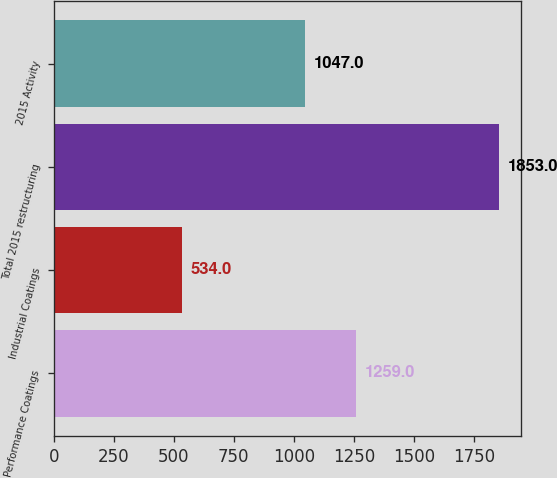Convert chart. <chart><loc_0><loc_0><loc_500><loc_500><bar_chart><fcel>Performance Coatings<fcel>Industrial Coatings<fcel>Total 2015 restructuring<fcel>2015 Activity<nl><fcel>1259<fcel>534<fcel>1853<fcel>1047<nl></chart> 